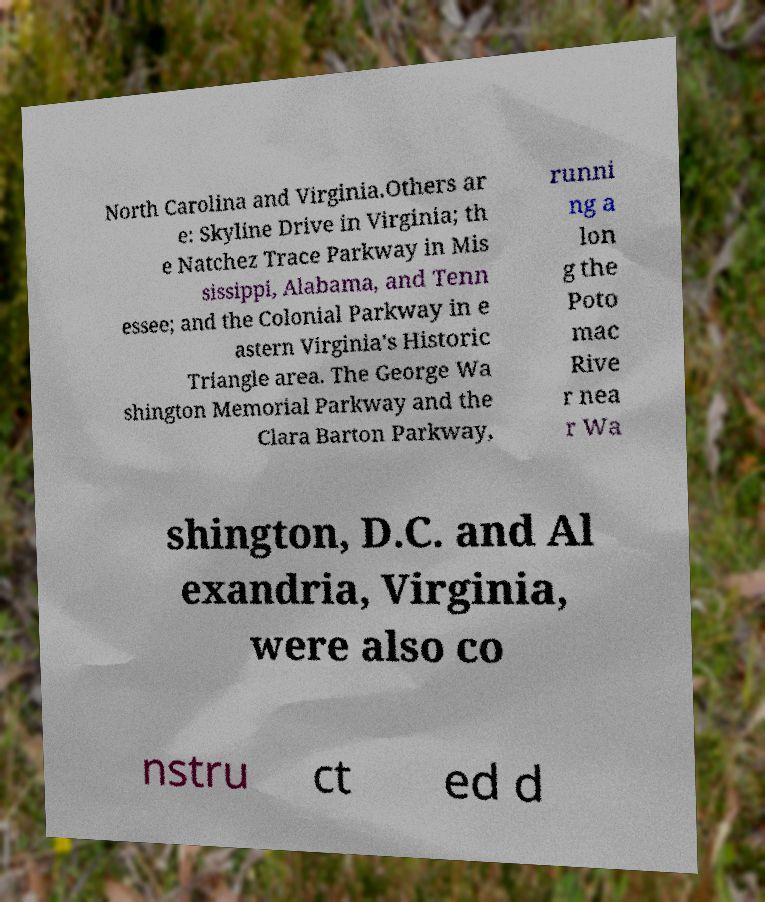Can you accurately transcribe the text from the provided image for me? North Carolina and Virginia.Others ar e: Skyline Drive in Virginia; th e Natchez Trace Parkway in Mis sissippi, Alabama, and Tenn essee; and the Colonial Parkway in e astern Virginia's Historic Triangle area. The George Wa shington Memorial Parkway and the Clara Barton Parkway, runni ng a lon g the Poto mac Rive r nea r Wa shington, D.C. and Al exandria, Virginia, were also co nstru ct ed d 